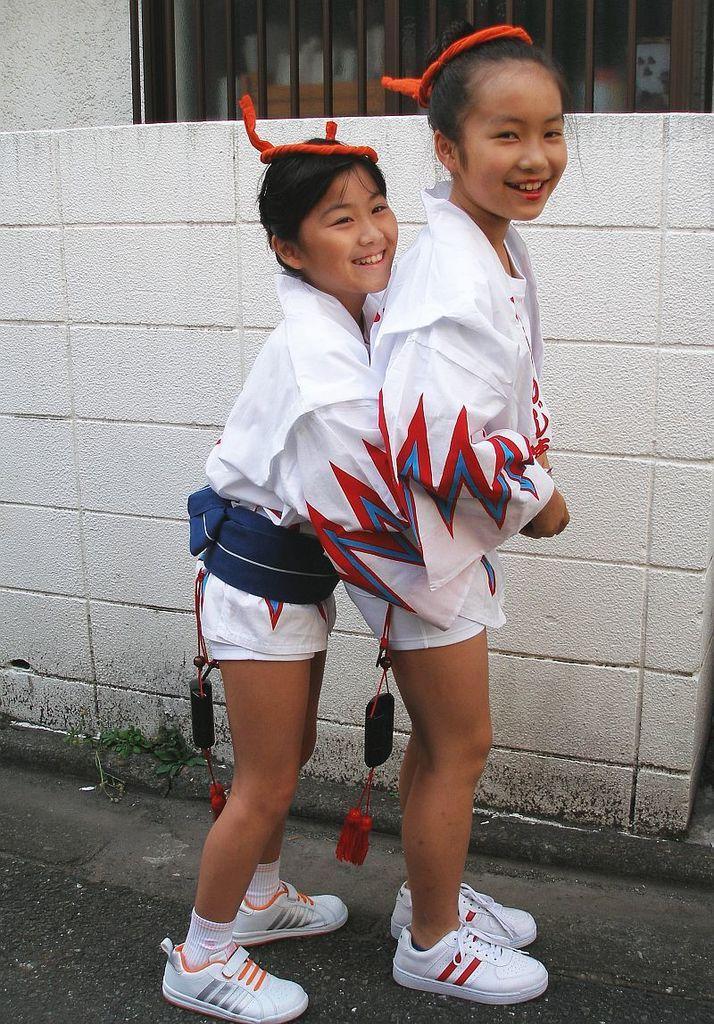How would you summarize this image in a sentence or two? In the center of the image two girls are standing. In the background of the image we can see wall, window are there. At the bottom of the image ground is there. 